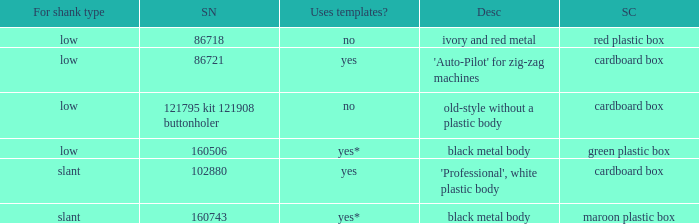What's the shank type of the buttonholer with red plastic box as storage case? Low. Could you parse the entire table as a dict? {'header': ['For shank type', 'SN', 'Uses templates?', 'Desc', 'SC'], 'rows': [['low', '86718', 'no', 'ivory and red metal', 'red plastic box'], ['low', '86721', 'yes', "'Auto-Pilot' for zig-zag machines", 'cardboard box'], ['low', '121795 kit 121908 buttonholer', 'no', 'old-style without a plastic body', 'cardboard box'], ['low', '160506', 'yes*', 'black metal body', 'green plastic box'], ['slant', '102880', 'yes', "'Professional', white plastic body", 'cardboard box'], ['slant', '160743', 'yes*', 'black metal body', 'maroon plastic box']]} 